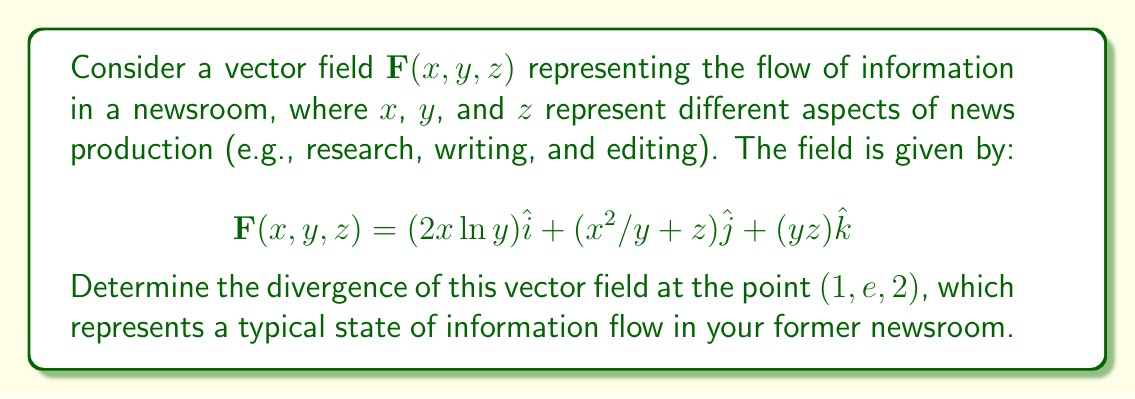Can you solve this math problem? To find the divergence of the vector field, we need to calculate the sum of the partial derivatives of each component with respect to its corresponding variable. The divergence is given by:

$$\text{div}\mathbf{F} = \nabla \cdot \mathbf{F} = \frac{\partial F_x}{\partial x} + \frac{\partial F_y}{\partial y} + \frac{\partial F_z}{\partial z}$$

Let's calculate each partial derivative:

1) $\frac{\partial F_x}{\partial x} = \frac{\partial}{\partial x}(2x\ln y) = 2\ln y$

2) $\frac{\partial F_y}{\partial y} = \frac{\partial}{\partial y}(x^2/y + z) = -x^2/y^2$

3) $\frac{\partial F_z}{\partial z} = \frac{\partial}{\partial z}(yz) = y$

Now, we sum these partial derivatives:

$$\text{div}\mathbf{F} = 2\ln y - x^2/y^2 + y$$

To evaluate this at the point $(1, e, 2)$, we substitute $x=1$, $y=e$, and $z=2$:

$$\text{div}\mathbf{F}(1, e, 2) = 2\ln e - 1^2/e^2 + e$$

Simplify:
$$\text{div}\mathbf{F}(1, e, 2) = 2 - 1/e^2 + e$$

This represents the rate at which information is being created or disseminated at the given point in the newsroom's information flow.
Answer: $2 - 1/e^2 + e$ 